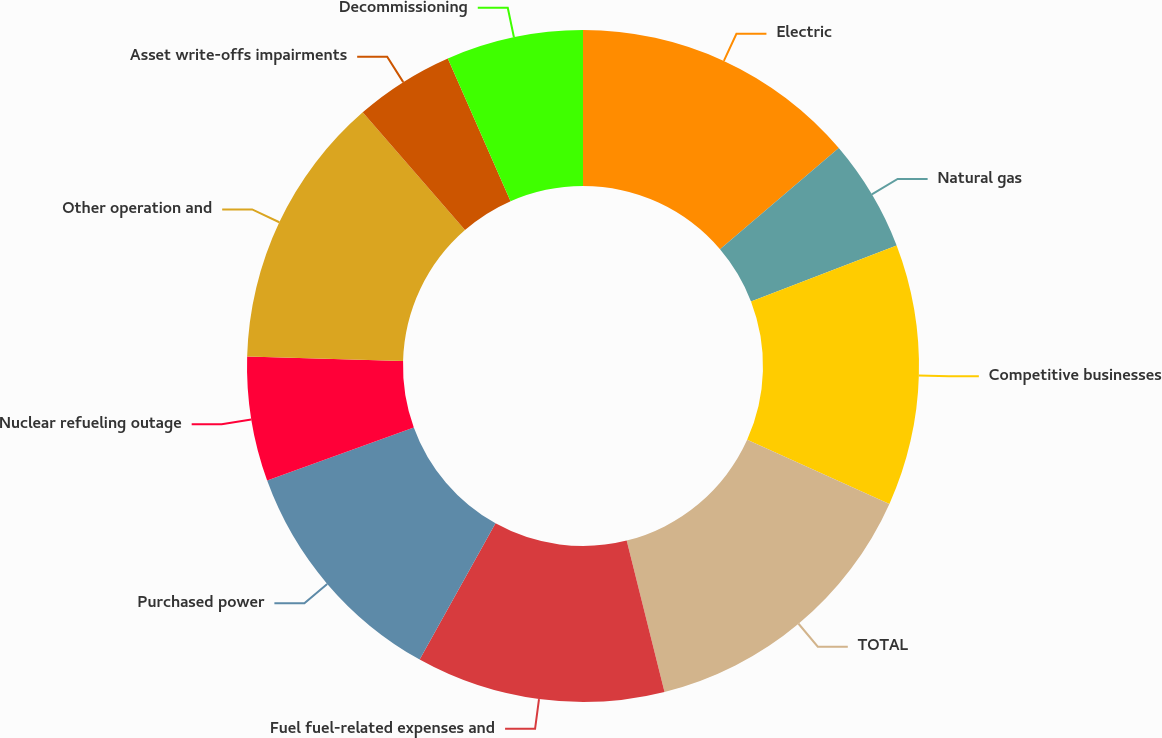Convert chart. <chart><loc_0><loc_0><loc_500><loc_500><pie_chart><fcel>Electric<fcel>Natural gas<fcel>Competitive businesses<fcel>TOTAL<fcel>Fuel fuel-related expenses and<fcel>Purchased power<fcel>Nuclear refueling outage<fcel>Other operation and<fcel>Asset write-offs impairments<fcel>Decommissioning<nl><fcel>13.77%<fcel>5.39%<fcel>12.57%<fcel>14.37%<fcel>11.98%<fcel>11.38%<fcel>5.99%<fcel>13.17%<fcel>4.79%<fcel>6.59%<nl></chart> 